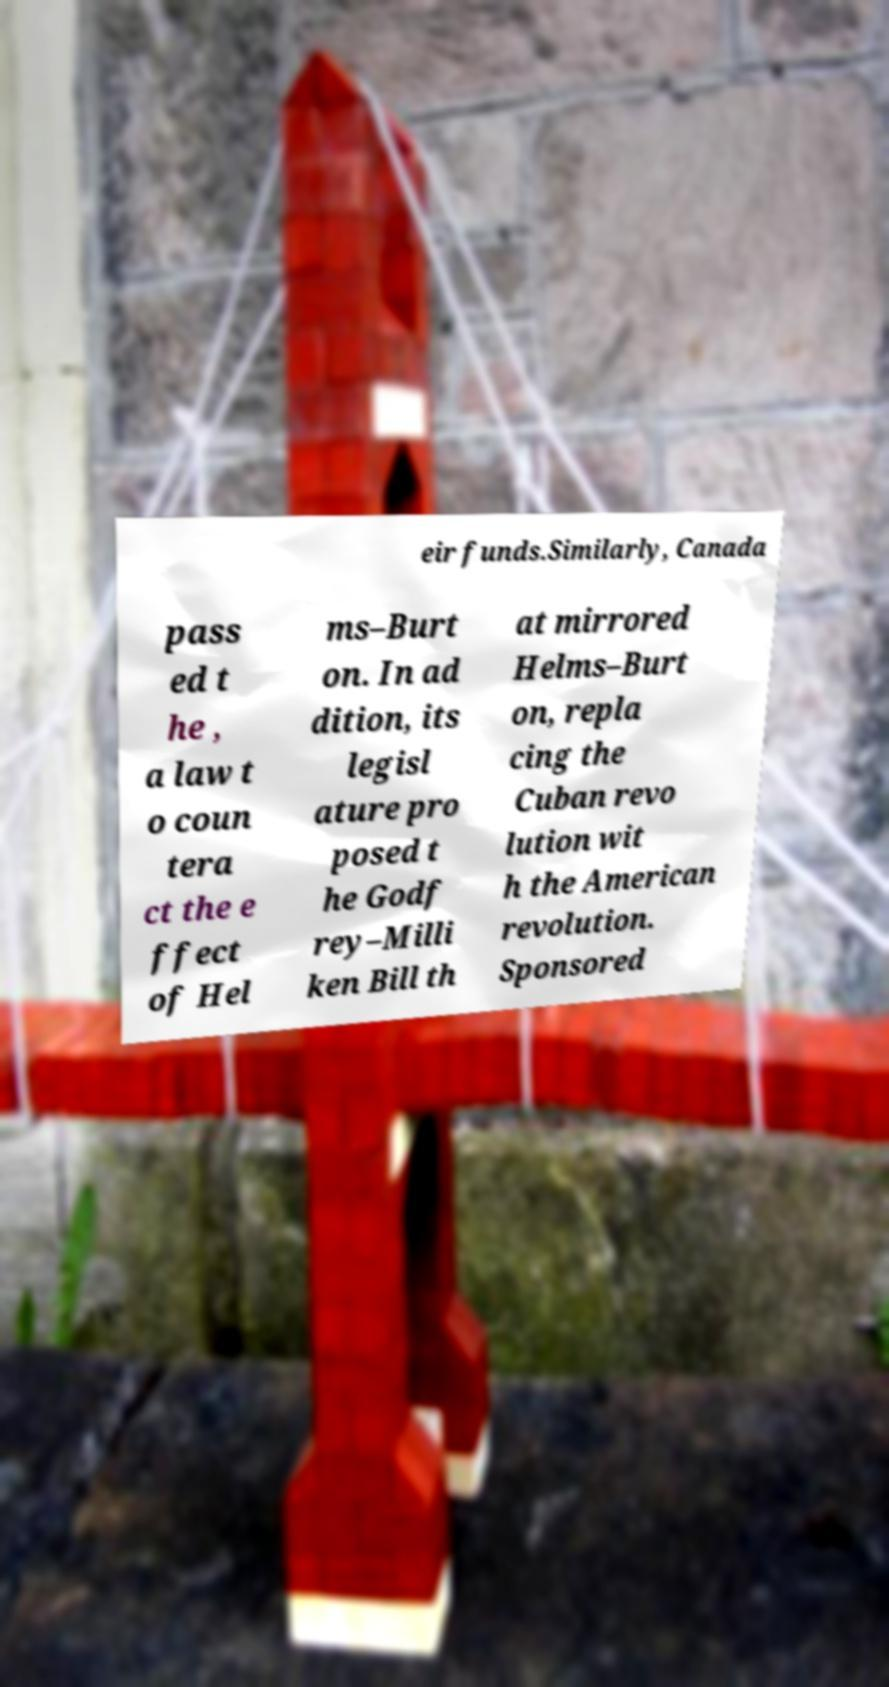Could you assist in decoding the text presented in this image and type it out clearly? eir funds.Similarly, Canada pass ed t he , a law t o coun tera ct the e ffect of Hel ms–Burt on. In ad dition, its legisl ature pro posed t he Godf rey–Milli ken Bill th at mirrored Helms–Burt on, repla cing the Cuban revo lution wit h the American revolution. Sponsored 